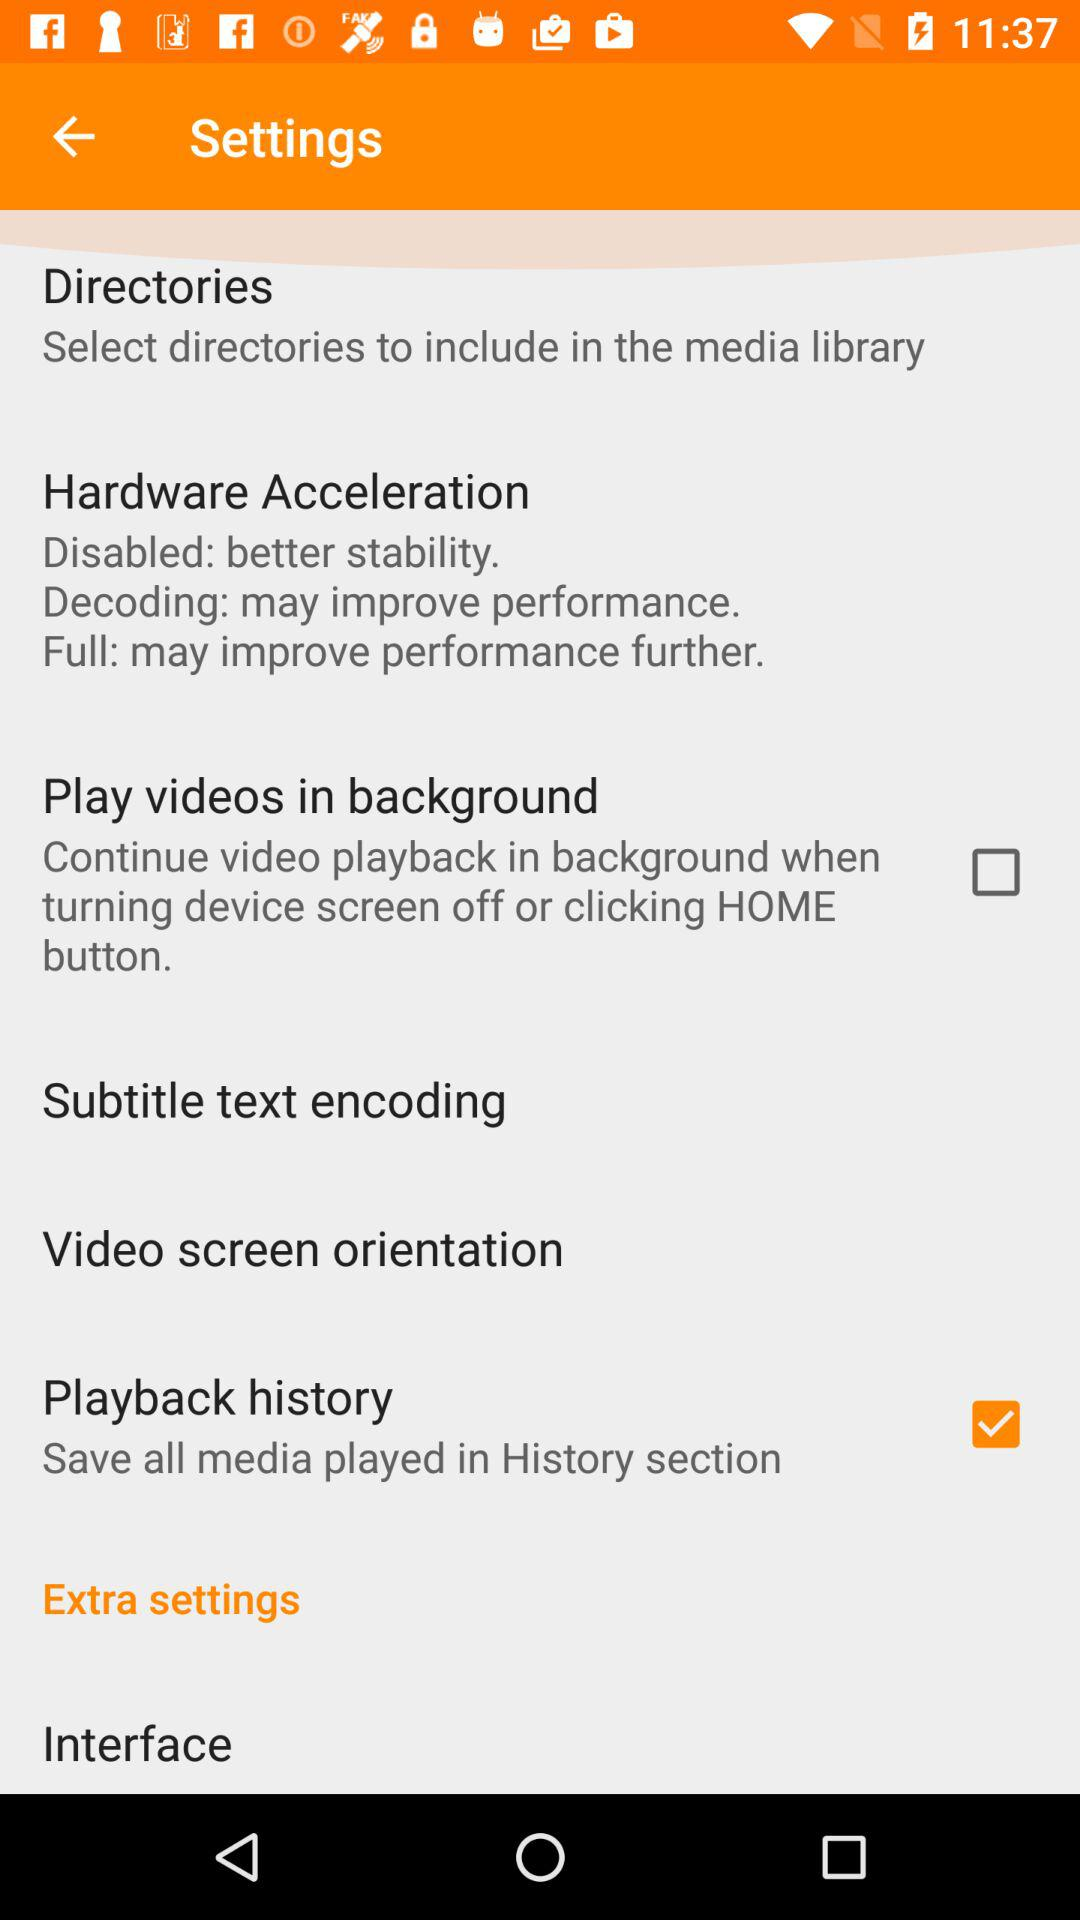What is the status of the "Playback history"? The status is "on". 